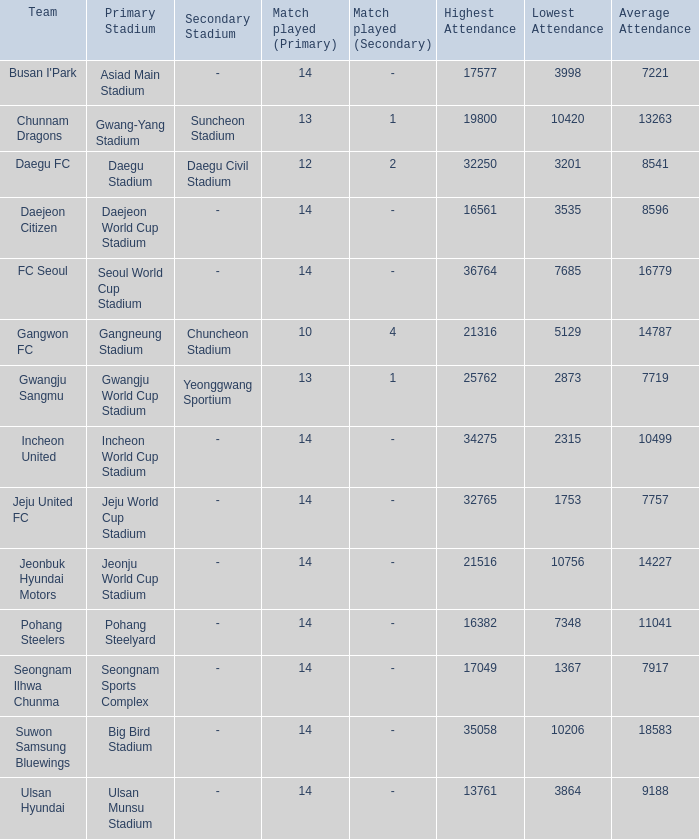What is the minimum when pohang steel yard is the arena? 7348.0. 